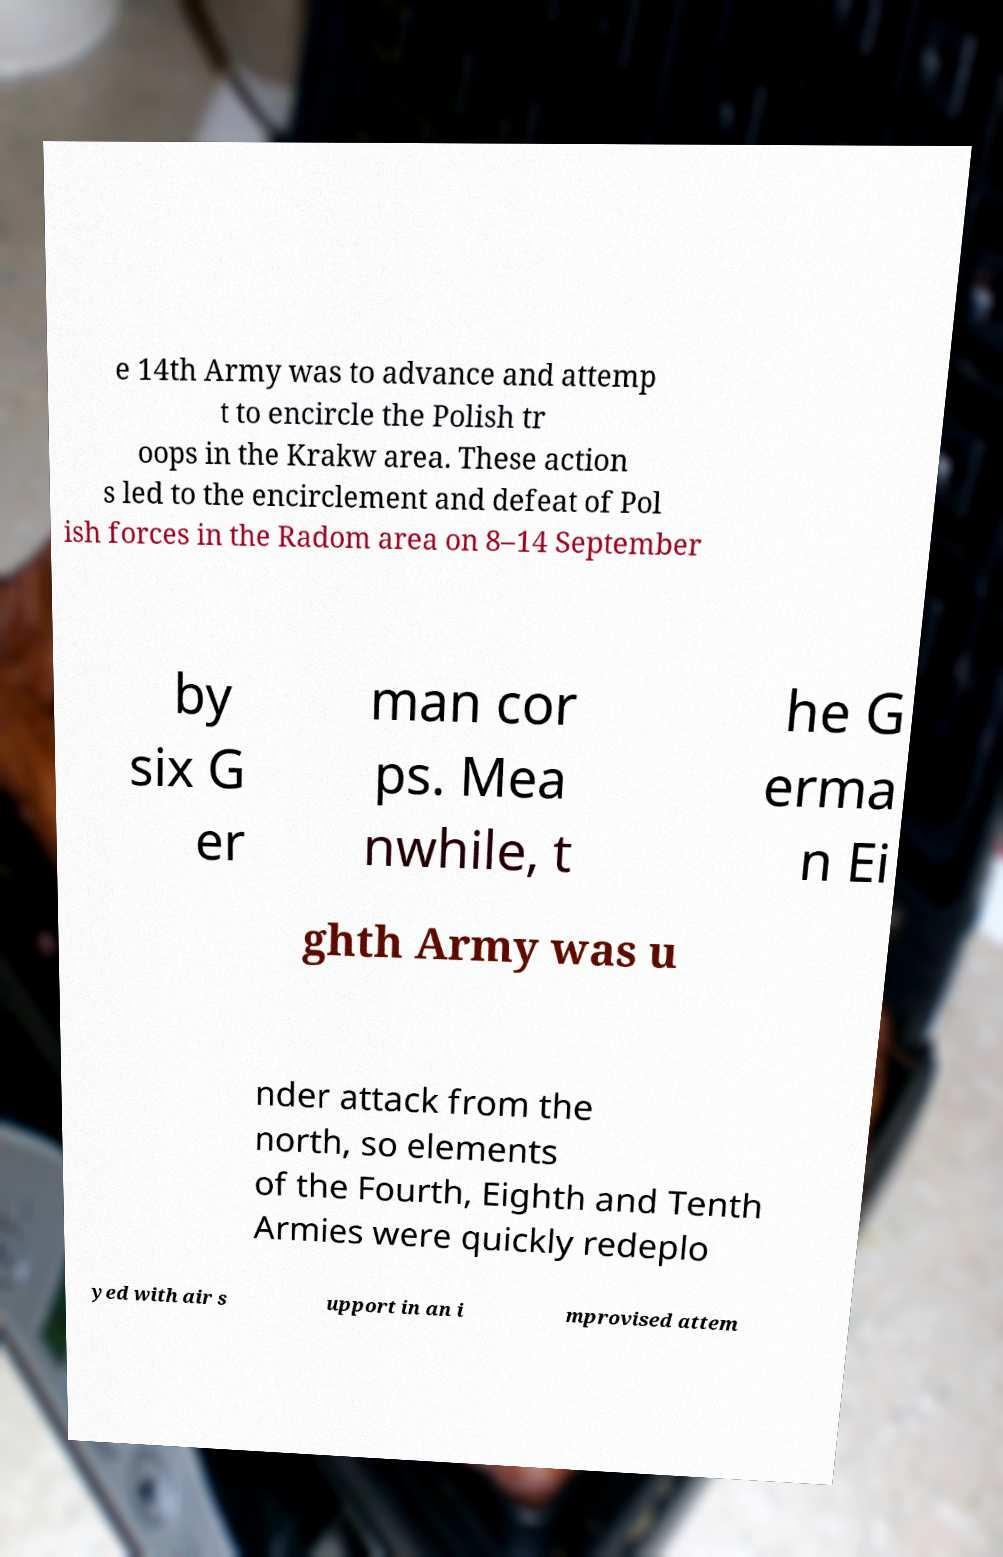Can you accurately transcribe the text from the provided image for me? e 14th Army was to advance and attemp t to encircle the Polish tr oops in the Krakw area. These action s led to the encirclement and defeat of Pol ish forces in the Radom area on 8–14 September by six G er man cor ps. Mea nwhile, t he G erma n Ei ghth Army was u nder attack from the north, so elements of the Fourth, Eighth and Tenth Armies were quickly redeplo yed with air s upport in an i mprovised attem 